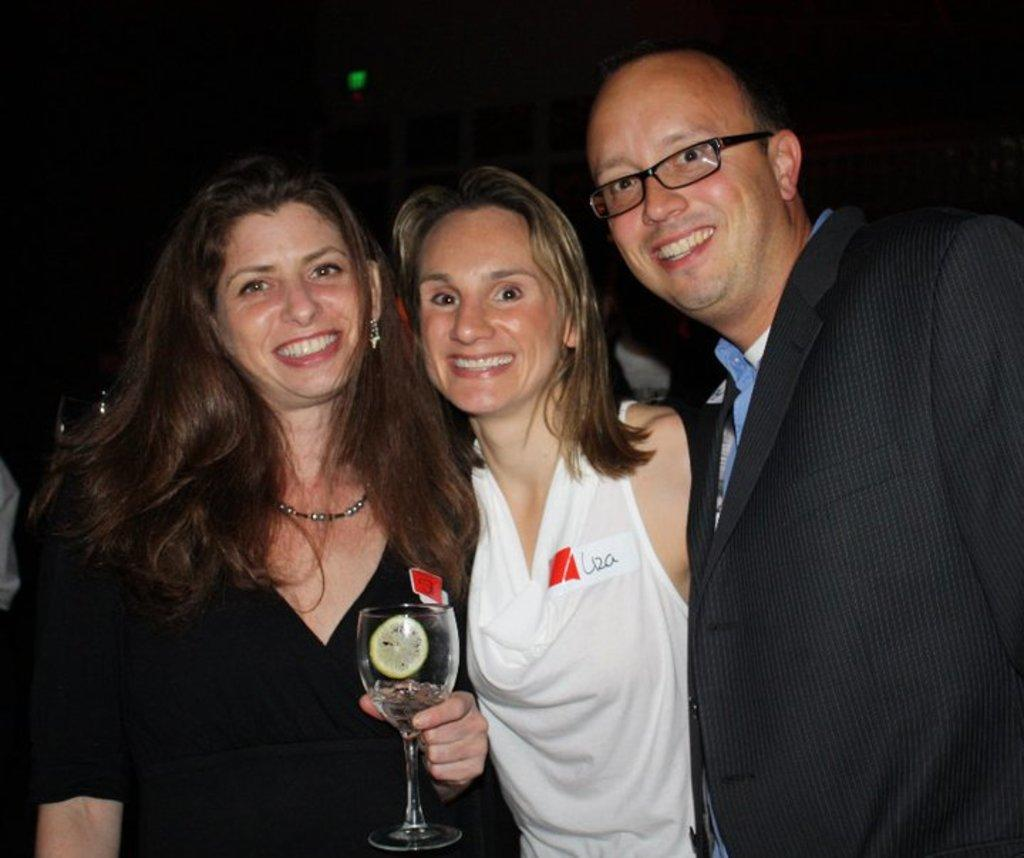How many people are in the image? There are three individuals in the image: one man and two women. What are the expressions on their faces? All three individuals are smiling in the image. What is one of the women holding? One of the women is holding a glass. What can be observed about the background of the image? The background of the image is dark. What type of card is the man holding in the image? There is no card present in the image; the man is not holding anything. What kind of quartz can be seen in the image? There is no quartz present in the image. 